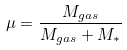Convert formula to latex. <formula><loc_0><loc_0><loc_500><loc_500>\mu = \frac { M _ { g a s } } { M _ { g a s } + M _ { * } }</formula> 